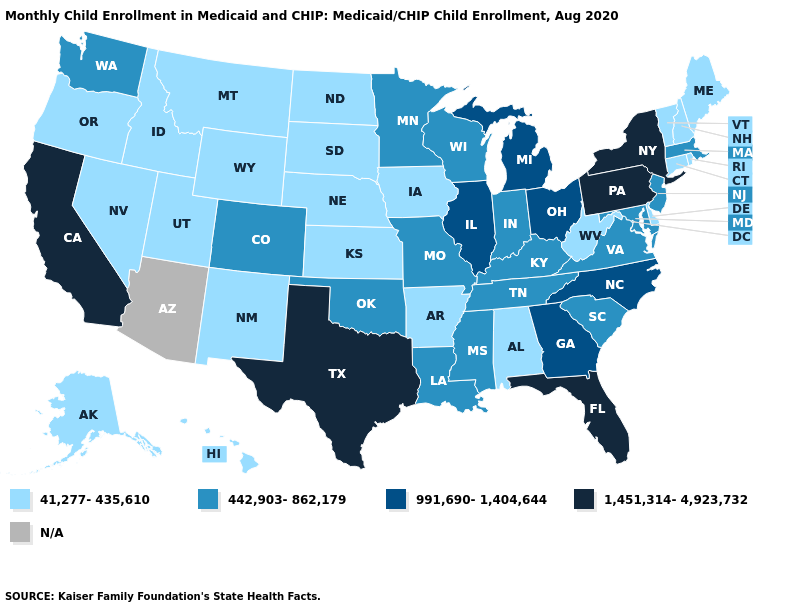What is the value of Idaho?
Quick response, please. 41,277-435,610. Name the states that have a value in the range 41,277-435,610?
Concise answer only. Alabama, Alaska, Arkansas, Connecticut, Delaware, Hawaii, Idaho, Iowa, Kansas, Maine, Montana, Nebraska, Nevada, New Hampshire, New Mexico, North Dakota, Oregon, Rhode Island, South Dakota, Utah, Vermont, West Virginia, Wyoming. What is the value of Michigan?
Write a very short answer. 991,690-1,404,644. Does Colorado have the lowest value in the West?
Concise answer only. No. Which states have the lowest value in the Northeast?
Be succinct. Connecticut, Maine, New Hampshire, Rhode Island, Vermont. Name the states that have a value in the range N/A?
Give a very brief answer. Arizona. Name the states that have a value in the range N/A?
Answer briefly. Arizona. What is the value of Maine?
Keep it brief. 41,277-435,610. Does Washington have the highest value in the West?
Short answer required. No. What is the value of Texas?
Give a very brief answer. 1,451,314-4,923,732. What is the value of Colorado?
Give a very brief answer. 442,903-862,179. What is the value of New Mexico?
Write a very short answer. 41,277-435,610. Does the first symbol in the legend represent the smallest category?
Be succinct. Yes. Among the states that border South Dakota , which have the highest value?
Answer briefly. Minnesota. 